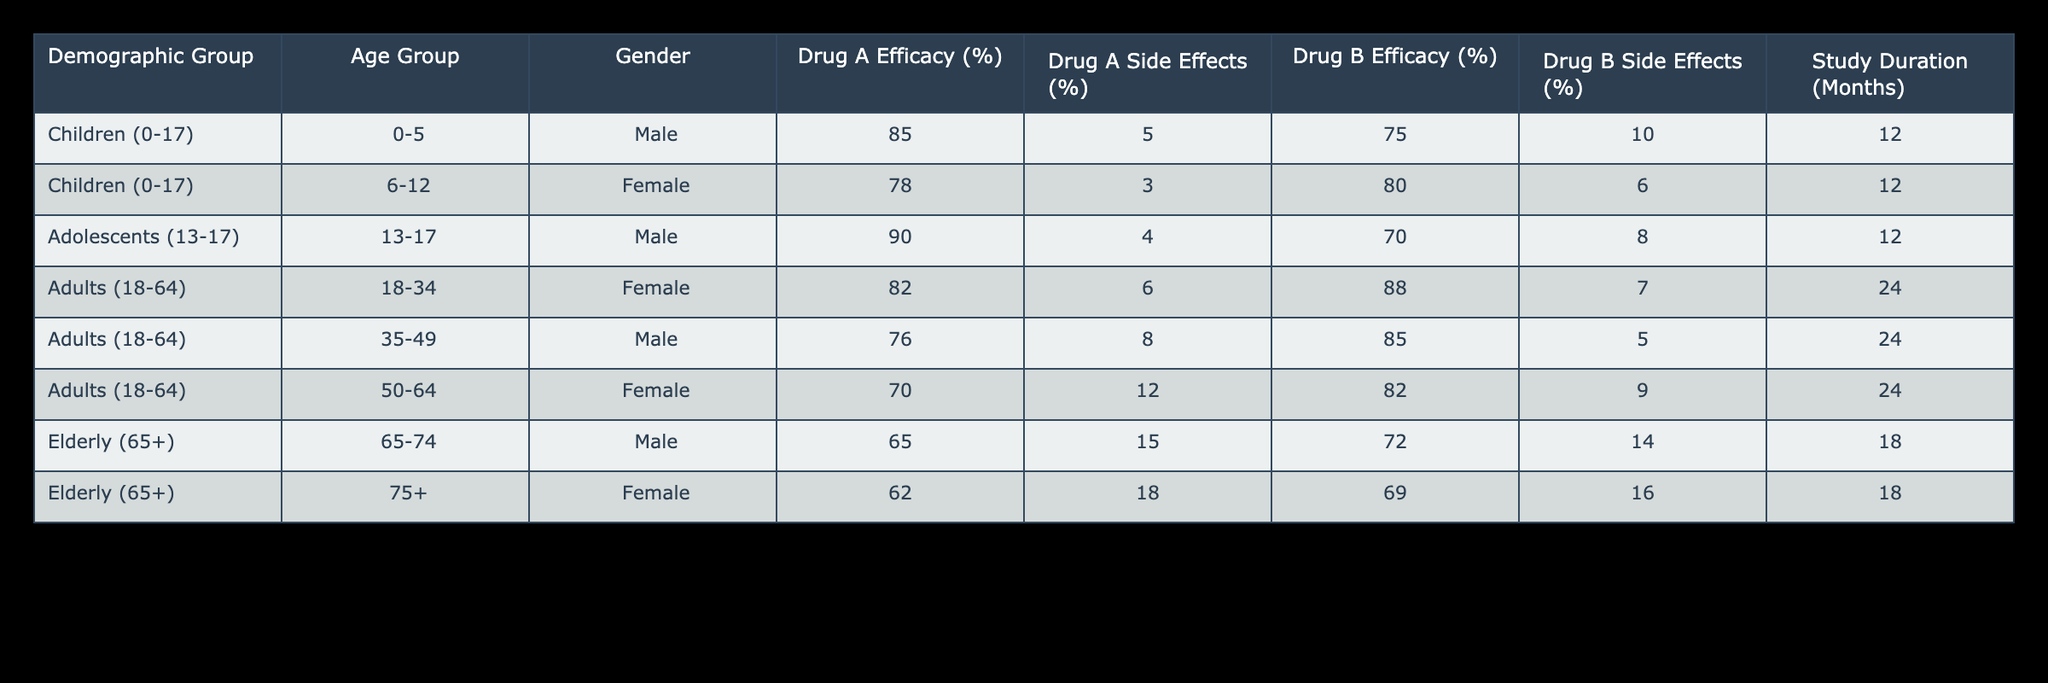What is the efficacy of Drug A in the Children (0-17) demographic group? The table shows the efficacy of Drug A for Children (0-5) at 85% and for Children (6-12) at 78%. By aggregating the efficacy for all children in this demographic, the values for Drug A are 85% and 78%, with no separate value for the combined group.
Answer: 85% (0-5), 78% (6-12) Which drug had more side effects in the Adults (18-64) demographic group? For Adults (18-34), Drug A had 6% side effects and Drug B had 7% side effects. For Adults (35-49), Drug A had 8% and Drug B had 5%. For Adults (50-64), Drug A had 12% while Drug B had 9%. Summarizing these, Drug A had side effects of 6%, 8%, and 12%, while Drug B had 7%, 5%, and 9%. The highest side effect percentage recorded between these demographics is 12% for Drug A and 9% for Drug B, indicating Drug A had more side effects overall in this group.
Answer: Drug A had more side effects What is the average efficacy of Drug B across all age groups? The efficacy percentages of Drug B are 75% (Children 0-5), 80% (Children 6-12), 70% (Adolescents 13-17), 88% (Adults 18-34), 85% (Adults 35-49), 82% (Adults 50-64), 72% (Elderly 65-74), and 69% (Elderly 75+). Adding up these values (75 + 80 + 70 + 88 + 85 + 82 + 72 + 69 =  619) gives a total of 619, divided by 8 demographic groups yields an average efficacy of 77.375%.
Answer: 77.375% Is the side effect percentage for Drug B in the 75+ age group higher than 15%? The table shows that Drug B's side effect percentage for the 75+ age group is 16%. By comparing this value directly, you can see that 16% is indeed higher than 15%.
Answer: Yes In which demographic group is Drug A more effective compared to Drug B? For children aged 0-5, Drug A is 85% effective, compared to Drug B at 75%. In the age group of 6-12, Drug A efficacy is 78% versus 80% for Drug B, where Drug B is more effective. For Adolescents 13-17, Drug A outperforms Drug B at 90% versus 70%. Similarly, in Adults 18-34, Drug A is at 82% while Drug B is 88%. In the 35-49 group, Drug A at 76% is less than Drug B at 85%. In Adults 50-64, Drug A at 70% is lower than Drug B at 82%. For the elderly, Drug A (65%) is less than Drug B (72%) for 65-74 and also less for 75+ where Drug A is at 62% versus 69%. Therefore, the only demographic where Drug A is more effective is among Adolescents (13-17).
Answer: Adolescents (13-17) 